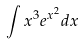Convert formula to latex. <formula><loc_0><loc_0><loc_500><loc_500>\int x ^ { 3 } e ^ { x ^ { 2 } } d x</formula> 